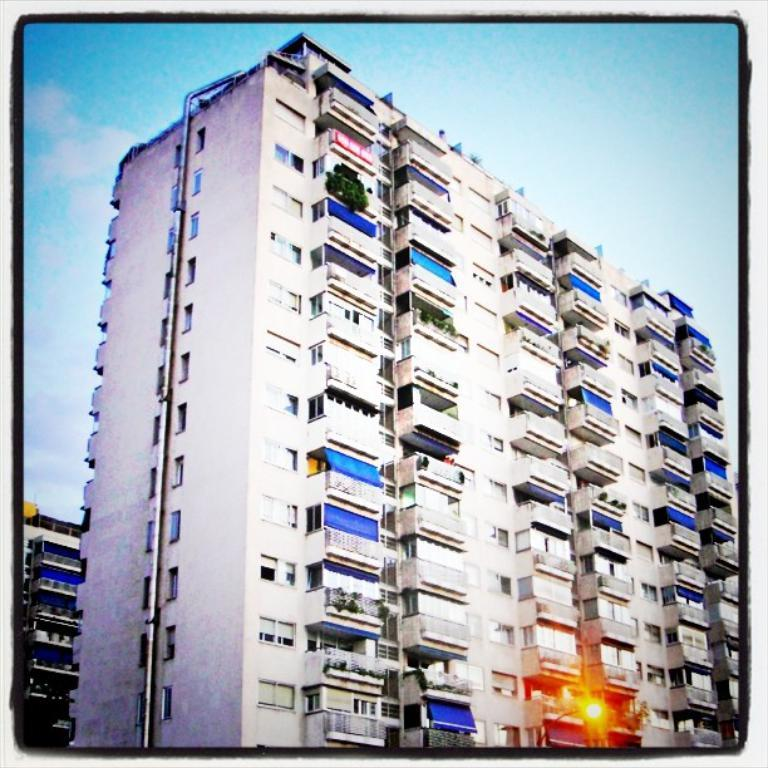What type of structures are present in the image? There are buildings in the image. What can be seen at the top of the image? The sky is visible at the top of the image. What feature do the buildings have? The buildings have windows. Where is the light located in the image? There is a light at the bottom of the image. What type of vegetation is visible in the image? There are plants visible in the image. What type of waves can be seen crashing against the buildings in the image? There are no waves present in the image; it features buildings with windows, plants, and a light at the bottom. Is there any salt visible on the plants in the image? There is no salt present in the image; it only features plants, buildings, and a light at the bottom. 